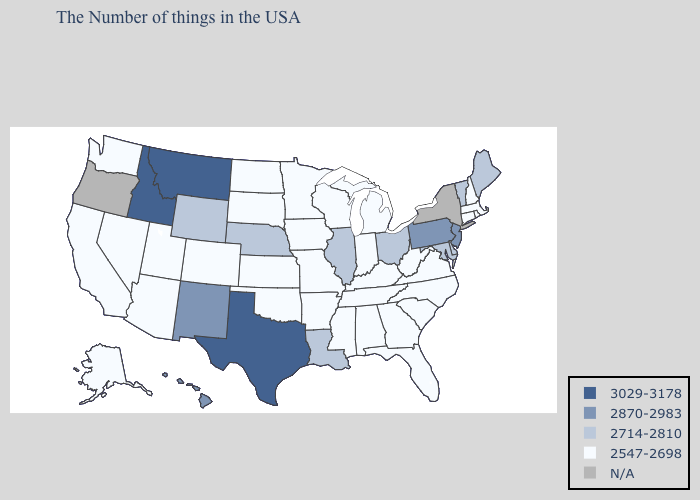What is the value of Vermont?
Quick response, please. 2714-2810. Name the states that have a value in the range 2714-2810?
Be succinct. Maine, Vermont, Delaware, Maryland, Ohio, Illinois, Louisiana, Nebraska, Wyoming. Which states have the lowest value in the USA?
Quick response, please. Massachusetts, Rhode Island, New Hampshire, Connecticut, Virginia, North Carolina, South Carolina, West Virginia, Florida, Georgia, Michigan, Kentucky, Indiana, Alabama, Tennessee, Wisconsin, Mississippi, Missouri, Arkansas, Minnesota, Iowa, Kansas, Oklahoma, South Dakota, North Dakota, Colorado, Utah, Arizona, Nevada, California, Washington, Alaska. What is the lowest value in states that border Nevada?
Keep it brief. 2547-2698. What is the value of Arkansas?
Short answer required. 2547-2698. What is the value of Maryland?
Quick response, please. 2714-2810. Does the map have missing data?
Be succinct. Yes. What is the highest value in states that border Michigan?
Be succinct. 2714-2810. Which states have the lowest value in the West?
Short answer required. Colorado, Utah, Arizona, Nevada, California, Washington, Alaska. What is the value of Pennsylvania?
Keep it brief. 2870-2983. What is the value of Ohio?
Write a very short answer. 2714-2810. Name the states that have a value in the range N/A?
Keep it brief. New York, Oregon. Among the states that border Iowa , which have the lowest value?
Quick response, please. Wisconsin, Missouri, Minnesota, South Dakota. 